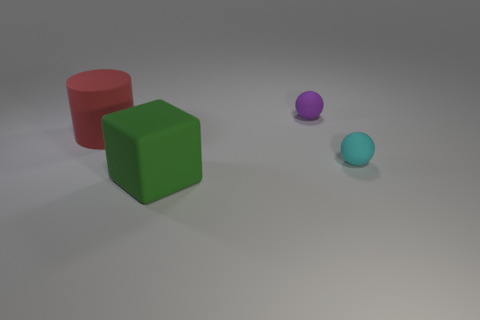Add 1 green metallic cylinders. How many objects exist? 5 Subtract all cylinders. How many objects are left? 3 Subtract 0 purple cylinders. How many objects are left? 4 Subtract all large cyan matte balls. Subtract all matte cubes. How many objects are left? 3 Add 1 big red cylinders. How many big red cylinders are left? 2 Add 3 big yellow metallic cylinders. How many big yellow metallic cylinders exist? 3 